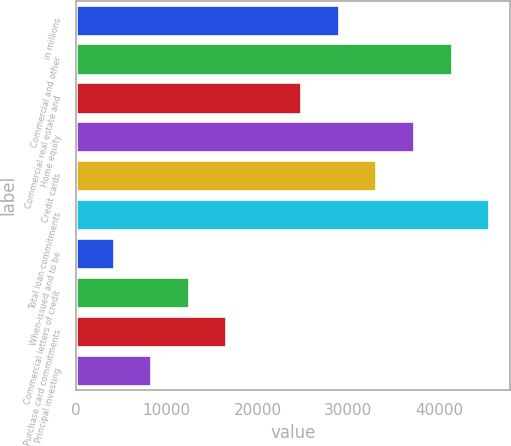<chart> <loc_0><loc_0><loc_500><loc_500><bar_chart><fcel>in millions<fcel>Commercial and other<fcel>Commercial real estate and<fcel>Home equity<fcel>Credit cards<fcel>Total loan commitments<fcel>When-issued and to be<fcel>Commercial letters of credit<fcel>Purchase card commitments<fcel>Principal investing<nl><fcel>28951.6<fcel>41359<fcel>24815.8<fcel>37223.2<fcel>33087.4<fcel>45494.8<fcel>4136.8<fcel>12408.4<fcel>16544.2<fcel>8272.6<nl></chart> 